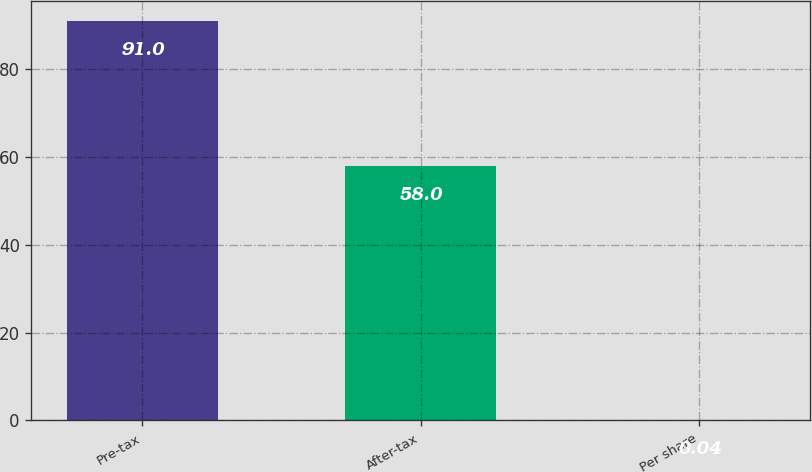Convert chart. <chart><loc_0><loc_0><loc_500><loc_500><bar_chart><fcel>Pre-tax<fcel>After-tax<fcel>Per share<nl><fcel>91<fcel>58<fcel>0.04<nl></chart> 